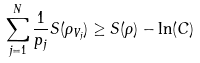Convert formula to latex. <formula><loc_0><loc_0><loc_500><loc_500>\sum _ { j = 1 } ^ { N } \frac { 1 } { p _ { j } } S ( \rho _ { V _ { j } } ) \geq S ( \rho ) - \ln ( C )</formula> 